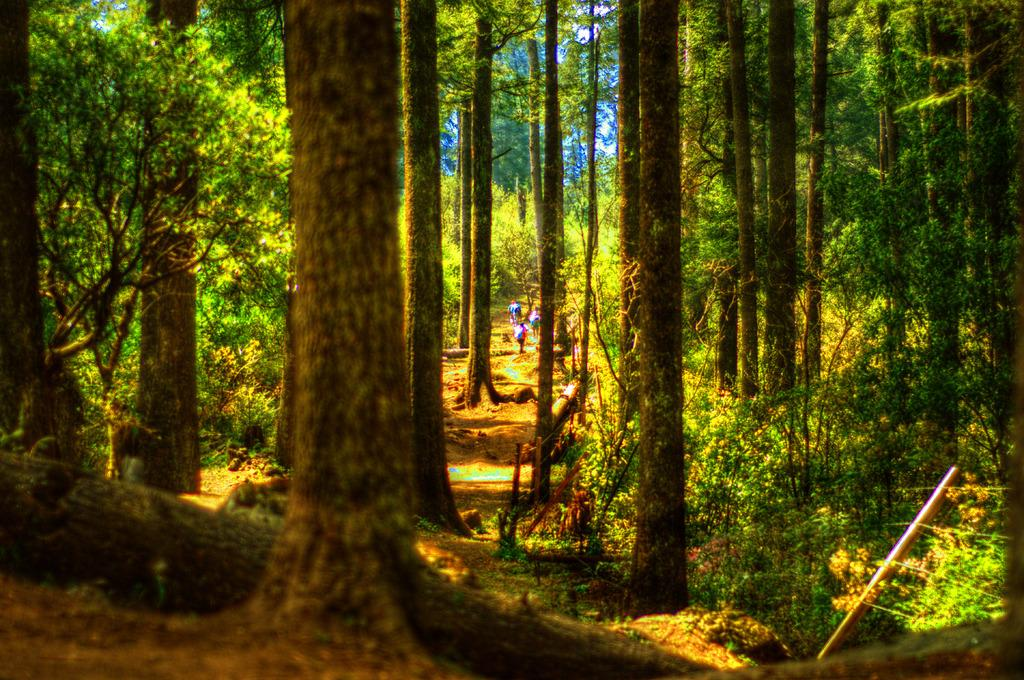What type of vegetation can be seen in the image? There are trees in the image. What structure is present in the image? There is a pole in the image. What else can be seen in the image besides trees and the pole? There are wires in the image. Are there any people visible in the image? Yes, there are people standing in the image. What type of birth can be seen taking place in the image? There is no birth taking place in the image; it only features trees, a pole, wires, and people standing. Can you tell me how many people are taking a bath in the image? There is no indication of anyone taking a bath in the image; it only shows people standing. 